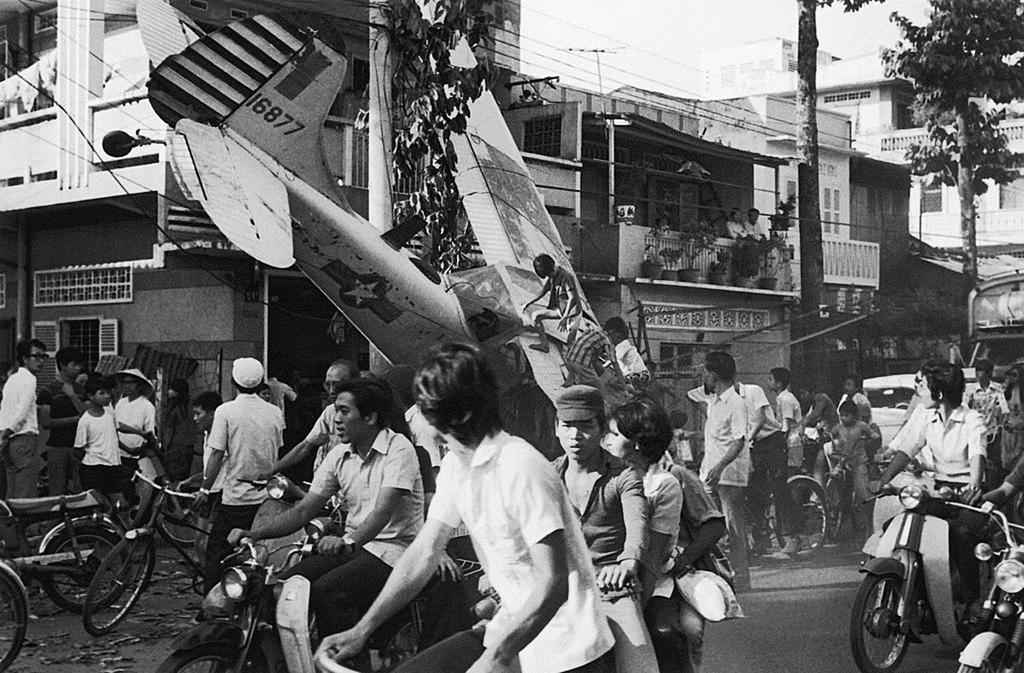Could you give a brief overview of what you see in this image? This is a black and white picture and it is a outdoor picture. At the top we can see sky. These are buildings. Here we can see persons riding vehicles on the road. 